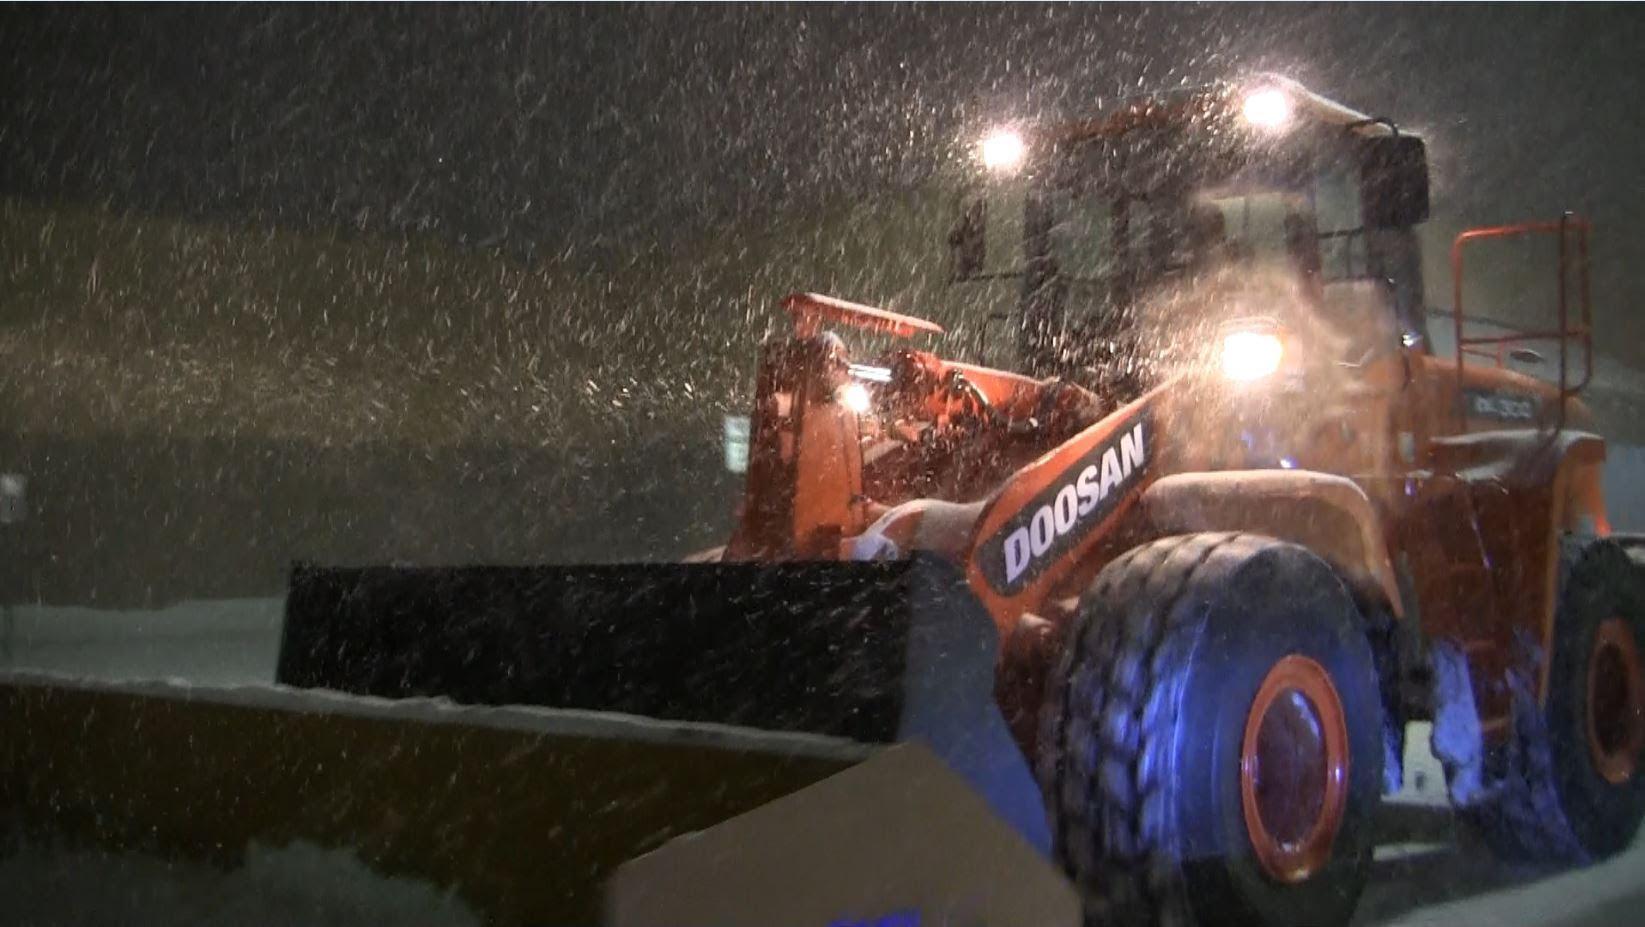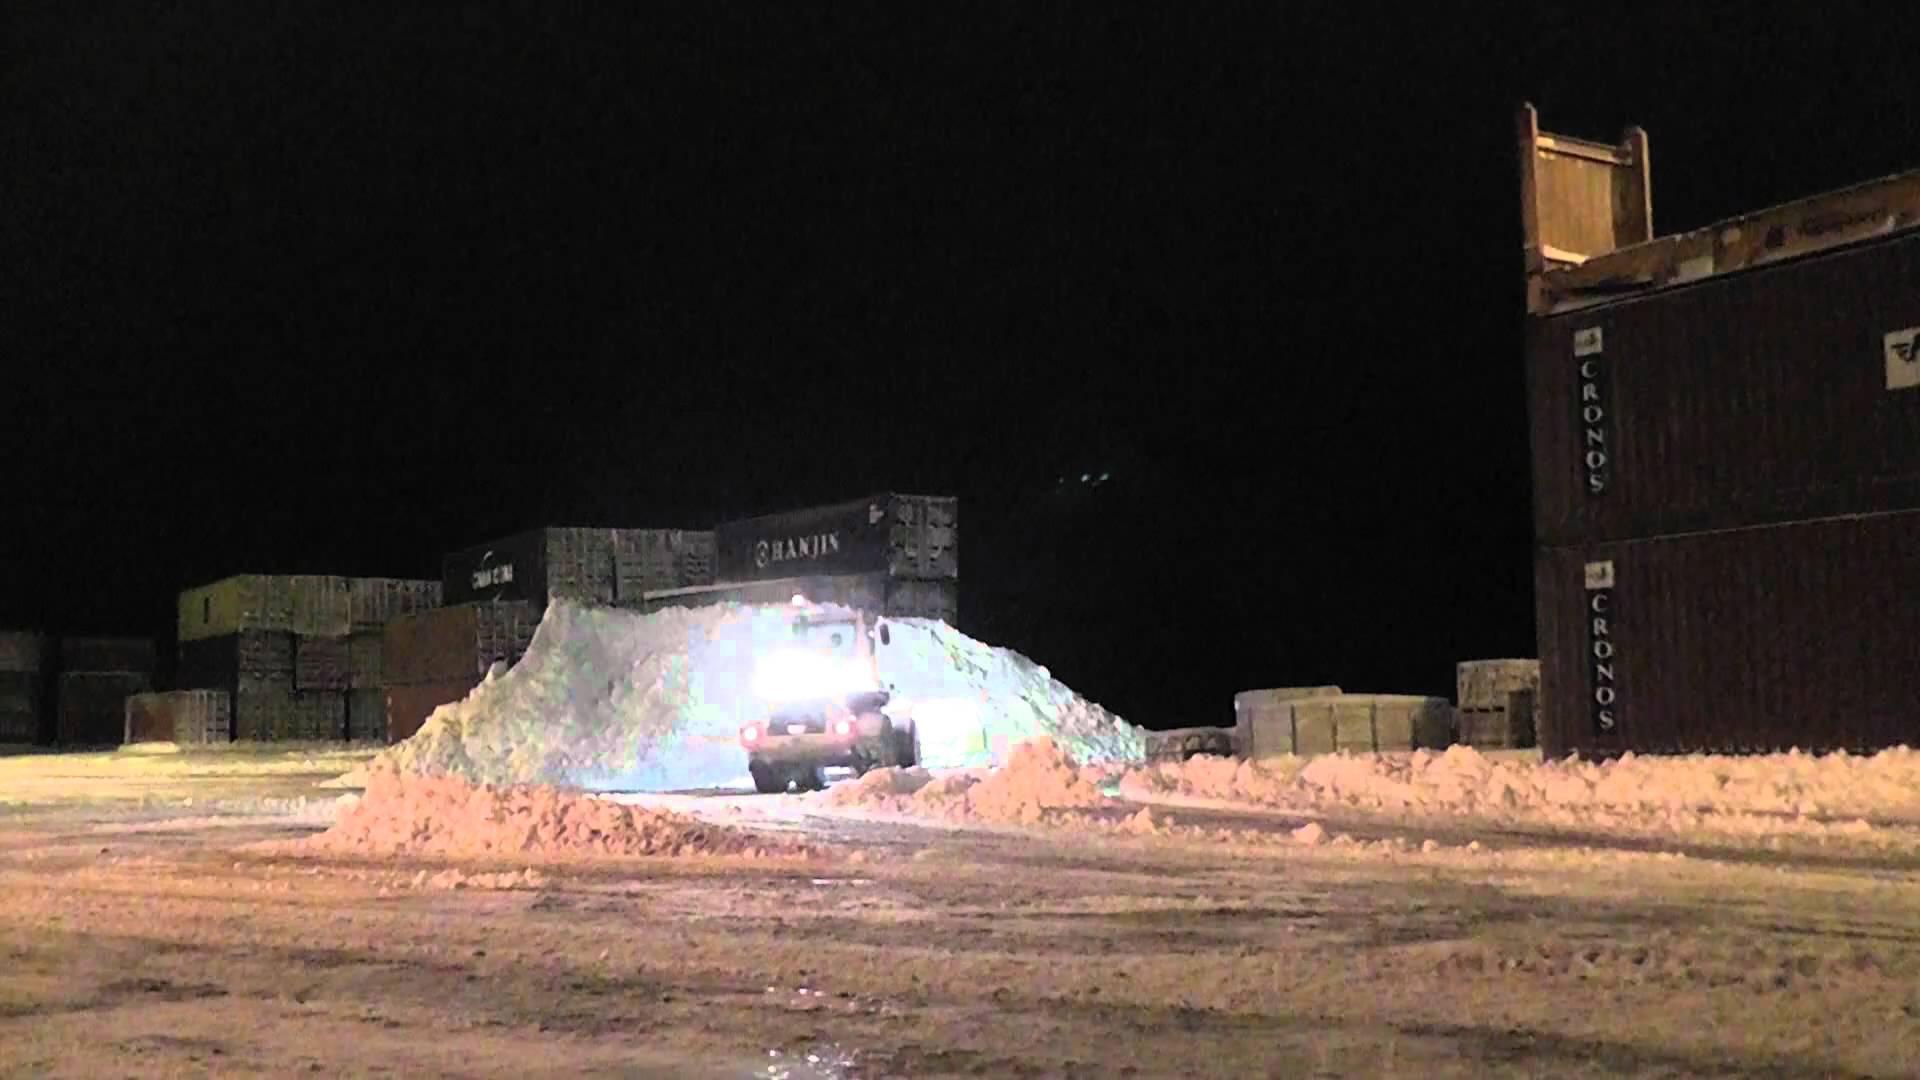The first image is the image on the left, the second image is the image on the right. Assess this claim about the two images: "An image shows a tractor-type plow with two bright white lights at the top pushing snow as the snow falls around it.". Correct or not? Answer yes or no. Yes. The first image is the image on the left, the second image is the image on the right. Considering the images on both sides, is "There is a total of two trackers plowing snow." valid? Answer yes or no. Yes. 